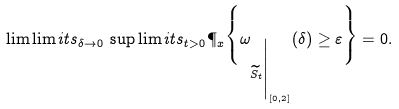Convert formula to latex. <formula><loc_0><loc_0><loc_500><loc_500>\lim \lim i t s _ { \delta \to 0 } \, \sup \lim i t s _ { t > 0 } \P _ { x } \Big \{ \omega _ { \widetilde { S } _ { t } \Big . \Big | _ { [ 0 , 2 ] } } ( \delta ) \geq \varepsilon \Big \} = 0 .</formula> 